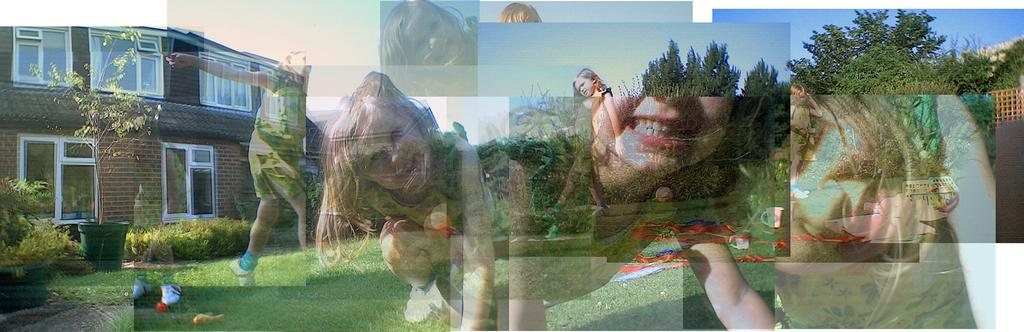What type of setting is depicted in the image? The image appears to depict a college setting. What type of vegetation can be seen in the image? There are plants in the image. What type of structure is present in the image? There is a house in the image. What can be seen in the background of the image? There are trees and the sky visible in the background of the image. What type of lock is used to secure the business in the image? There is no business present in the image, and therefore no lock can be observed. 